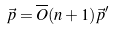Convert formula to latex. <formula><loc_0><loc_0><loc_500><loc_500>\vec { p } = \overline { O } ( n + 1 ) \vec { p } ^ { \prime }</formula> 